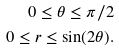Convert formula to latex. <formula><loc_0><loc_0><loc_500><loc_500>0 \leq \theta \leq \pi / 2 \\ 0 \leq r \leq \sin ( 2 \theta ) .</formula> 